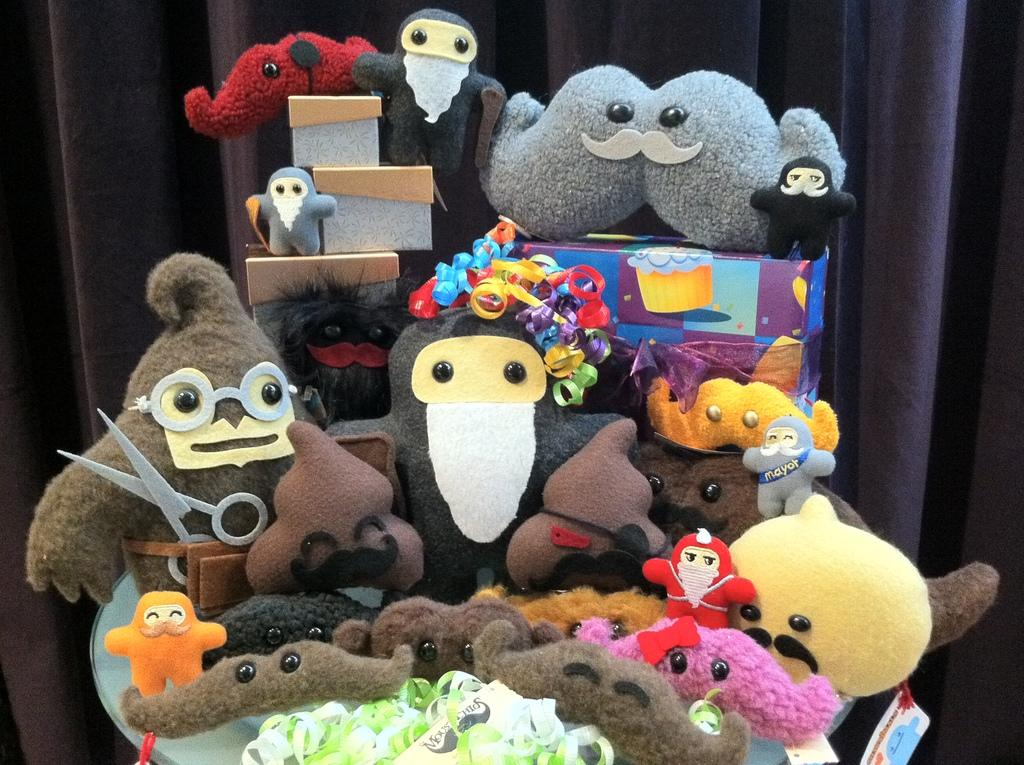What type of objects can be seen in the image? There are toys and boxes in the image. Are there any additional decorative elements in the image? Yes, decorative lights are present in the image. Where are the objects located? The objects are on a platform. What can be seen in the background of the image? There is a curtain in the background of the image. What type of paste is being used to stick the flowers on the platform in the image? There are no flowers or paste present in the image; it features toys, boxes, decorative lights, and a curtain. 